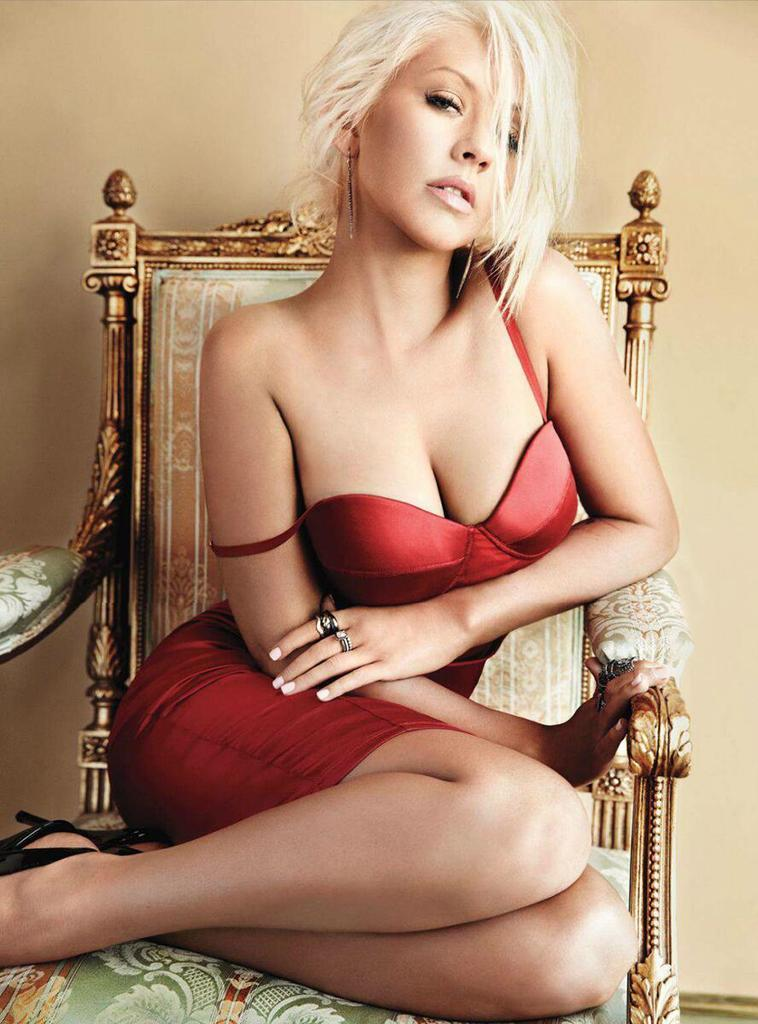Who or what is present in the image? There is a person in the image. What is the person doing in the image? The person is sitting on a chair. What can be seen in the background of the image? There is a wall in the background of the image. How many sheep are visible in the image? There are no sheep present in the image. What is the distance between the person and the wall in the image? The distance between the person and the wall cannot be determined from the image alone. 